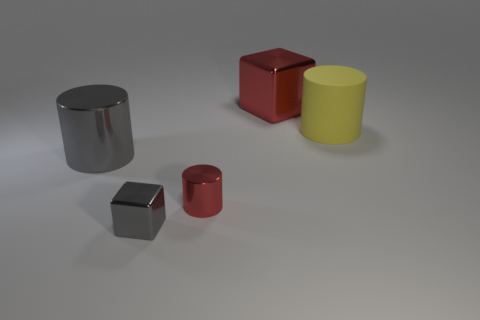Add 5 large gray things. How many objects exist? 10 Subtract all blocks. How many objects are left? 3 Subtract all red cylinders. Subtract all yellow matte things. How many objects are left? 3 Add 5 small shiny cubes. How many small shiny cubes are left? 6 Add 4 large objects. How many large objects exist? 7 Subtract 0 brown cubes. How many objects are left? 5 